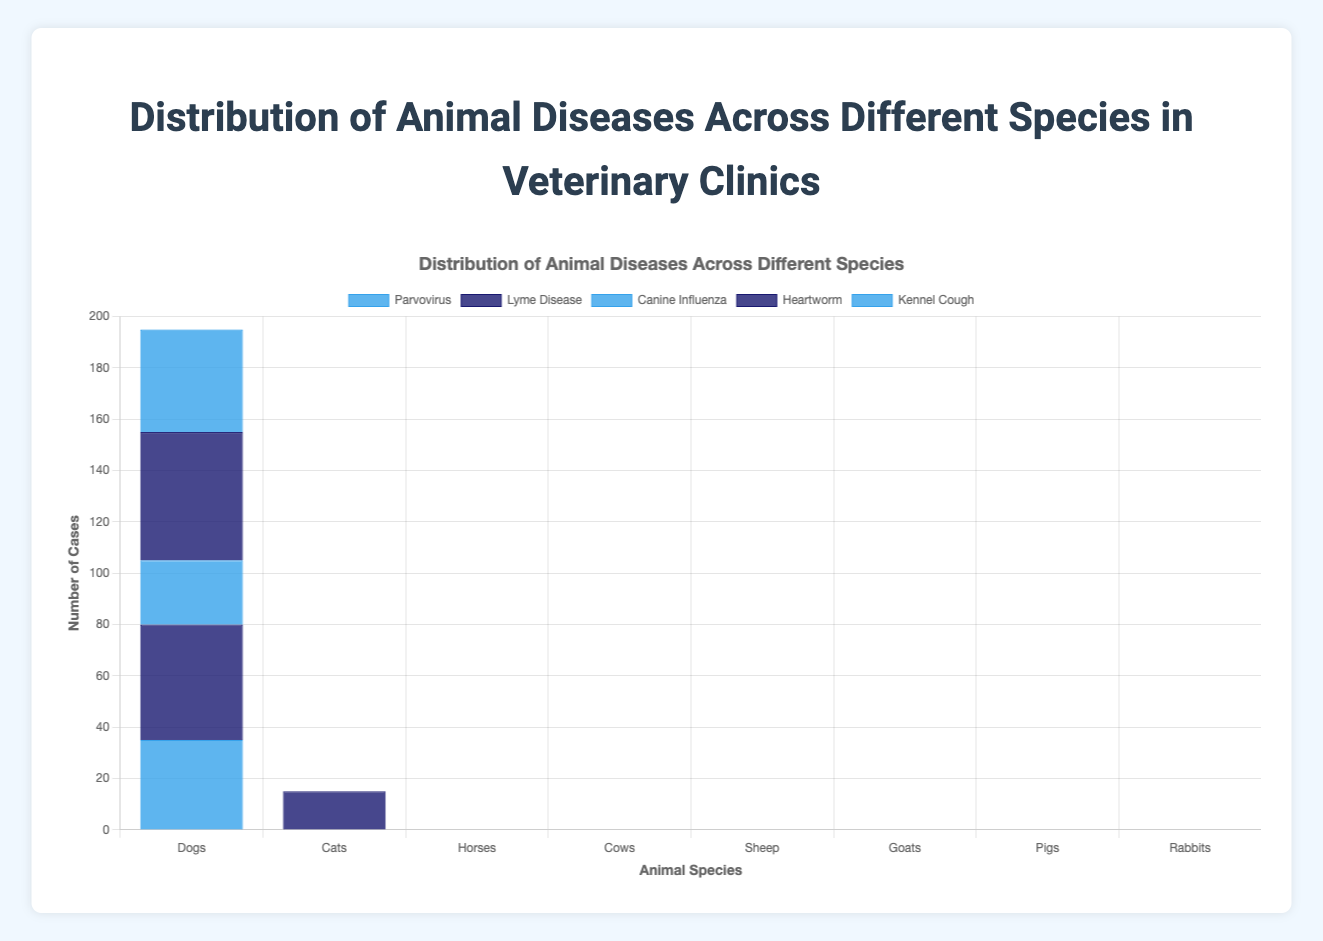What species suffers the most from respiratory diseases? To determine which species suffers the most from respiratory diseases, we look at the count of such diseases for each species. The data shows: Dogs: 0, Cats: 35, Horses: 18, Cows: 30, Sheep: 22, Goats: 20, Pigs: 18, Rabbits: 20. Among these, Cats suffer the most from respiratory diseases with a count of 35.
Answer: Cats Which disease has the highest occurrence among dogs? The figure shows the diseases and their occurrences in dogs. Comparing the counts: Parvovirus: 35, Lyme Disease: 45, Canine Influenza: 25, Heartworm: 50, Kennel Cough: 40. The highest occurrence is Heartworm with a count of 50.
Answer: Heartworm What is the difference between the total number of disease cases in cows and pigs? To find the total number of disease cases in cows and pigs, sum up the individual counts. For Cows: 40 + 50 + 15 + 30 + 20 = 155. For Pigs: 35 + 20 + 25 + 30 + 18 = 128. The difference is 155 - 128 = 27.
Answer: 27 Is Lyme Disease more prevalent in dogs or Feline Leukemia in cats? Compare the count of Lyme Disease in dogs and Feline Leukemia in cats. Lyme Disease in dogs is 45, Feline Leukemia in cats is 30. Therefore, Lyme Disease is more prevalent in dogs.
Answer: Lyme Disease in dogs Which species has the fewest disease cases overall, and what is the total count for that species? Sum the disease cases for each species to determine which has the fewest. Dogs: 35+45+25+50+40=195, Cats: 30+28+20+15+35=128, Horses: 15+20+10+18+12=75, Cows: 40+50+15+30+20=155, Sheep: 14+25+10+22+8=79, Goats: 12+10+18+14+20=74, Pigs: 35+20+25+30+18=128, Rabbits: 15+12+18+20+25=90. The species with the fewest cases is Goats with a total count of 74.
Answer: Goats, 74 What disease is most prevalent among rabbits and what is its count? Checking the rabbit diseases and their counts, we have Myxomatosis: 15, Rabbit Hemorrhagic Disease: 12, Pasteurellosis: 18, Coccidiosis: 20, Ear Mites: 25. The most prevalent disease in rabbits is Ear Mites with a count of 25.
Answer: Ear Mites On average, how many heartworm cases are reported across all species? First, sum up the heartworm cases for the species where it is reported: Dogs: 50, Cats: 15. Total cases = 50 + 15 = 65. There are 2 species. The average is 65 / 2 = 32.5.
Answer: 32.5 How does the total number of disease cases in sheep compare to rabbits? Sum the total disease cases for both species and compare. Sheep: 14+25+10+22+8=79, Rabbits: 15+12+18+20+25=90. Sheep have fewer cases than rabbits (79 < 90).
Answer: Rabbits have more What is the combined count of bovine viral diarrhea and mastitis in cows? Adding the counts of bovine viral diarrhea and mastitis in cows gives: 40 (bovine viral diarrhea) + 50 (mastitis) = 90.
Answer: 90 Which species has the highest number of mastitis cases? Only cows are mentioned with mastitis cases, listed at 50. Thus, cows have the highest number of mastitis cases.
Answer: Cows 